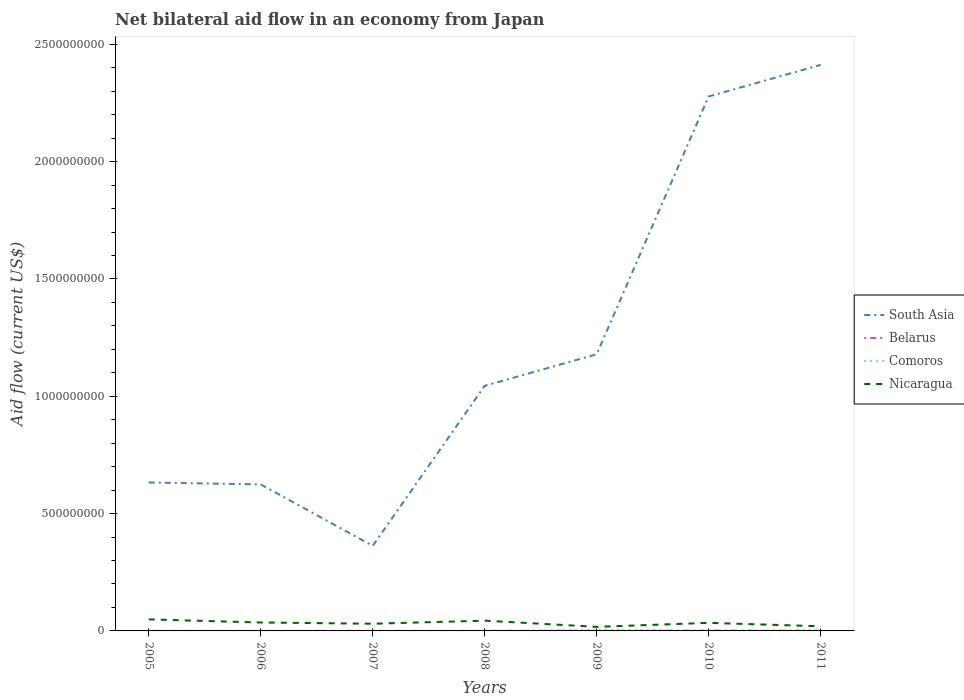How many different coloured lines are there?
Make the answer very short. 4. Does the line corresponding to South Asia intersect with the line corresponding to Belarus?
Your answer should be compact. No. Is the number of lines equal to the number of legend labels?
Keep it short and to the point. Yes. Across all years, what is the maximum net bilateral aid flow in Nicaragua?
Offer a terse response. 1.74e+07. In which year was the net bilateral aid flow in Comoros maximum?
Keep it short and to the point. 2007. What is the total net bilateral aid flow in South Asia in the graph?
Offer a terse response. -4.20e+08. What is the difference between the highest and the second highest net bilateral aid flow in Nicaragua?
Ensure brevity in your answer.  3.18e+07. Is the net bilateral aid flow in South Asia strictly greater than the net bilateral aid flow in Belarus over the years?
Ensure brevity in your answer.  No. How many lines are there?
Keep it short and to the point. 4. Does the graph contain any zero values?
Your answer should be compact. No. Does the graph contain grids?
Your answer should be very brief. No. Where does the legend appear in the graph?
Your answer should be compact. Center right. What is the title of the graph?
Your answer should be very brief. Net bilateral aid flow in an economy from Japan. What is the label or title of the X-axis?
Keep it short and to the point. Years. What is the Aid flow (current US$) in South Asia in 2005?
Make the answer very short. 6.33e+08. What is the Aid flow (current US$) in Nicaragua in 2005?
Offer a terse response. 4.92e+07. What is the Aid flow (current US$) of South Asia in 2006?
Provide a succinct answer. 6.24e+08. What is the Aid flow (current US$) in Belarus in 2006?
Ensure brevity in your answer.  1.60e+05. What is the Aid flow (current US$) of Nicaragua in 2006?
Offer a very short reply. 3.59e+07. What is the Aid flow (current US$) of South Asia in 2007?
Keep it short and to the point. 3.63e+08. What is the Aid flow (current US$) in Belarus in 2007?
Your answer should be very brief. 3.70e+05. What is the Aid flow (current US$) in Nicaragua in 2007?
Your answer should be very brief. 3.06e+07. What is the Aid flow (current US$) in South Asia in 2008?
Keep it short and to the point. 1.04e+09. What is the Aid flow (current US$) in Belarus in 2008?
Make the answer very short. 4.20e+05. What is the Aid flow (current US$) of Nicaragua in 2008?
Your response must be concise. 4.38e+07. What is the Aid flow (current US$) of South Asia in 2009?
Ensure brevity in your answer.  1.18e+09. What is the Aid flow (current US$) of Belarus in 2009?
Your answer should be compact. 5.70e+05. What is the Aid flow (current US$) in Comoros in 2009?
Offer a terse response. 5.30e+06. What is the Aid flow (current US$) of Nicaragua in 2009?
Offer a very short reply. 1.74e+07. What is the Aid flow (current US$) in South Asia in 2010?
Your answer should be very brief. 2.28e+09. What is the Aid flow (current US$) in Belarus in 2010?
Provide a succinct answer. 1.39e+06. What is the Aid flow (current US$) in Nicaragua in 2010?
Keep it short and to the point. 3.44e+07. What is the Aid flow (current US$) of South Asia in 2011?
Provide a succinct answer. 2.41e+09. What is the Aid flow (current US$) of Comoros in 2011?
Your response must be concise. 3.66e+06. What is the Aid flow (current US$) of Nicaragua in 2011?
Ensure brevity in your answer.  1.98e+07. Across all years, what is the maximum Aid flow (current US$) of South Asia?
Your response must be concise. 2.41e+09. Across all years, what is the maximum Aid flow (current US$) of Belarus?
Provide a succinct answer. 1.39e+06. Across all years, what is the maximum Aid flow (current US$) of Comoros?
Your response must be concise. 5.30e+06. Across all years, what is the maximum Aid flow (current US$) of Nicaragua?
Ensure brevity in your answer.  4.92e+07. Across all years, what is the minimum Aid flow (current US$) of South Asia?
Provide a short and direct response. 3.63e+08. Across all years, what is the minimum Aid flow (current US$) in Nicaragua?
Give a very brief answer. 1.74e+07. What is the total Aid flow (current US$) of South Asia in the graph?
Give a very brief answer. 8.53e+09. What is the total Aid flow (current US$) in Belarus in the graph?
Your response must be concise. 3.40e+06. What is the total Aid flow (current US$) in Comoros in the graph?
Your response must be concise. 9.79e+06. What is the total Aid flow (current US$) in Nicaragua in the graph?
Provide a succinct answer. 2.31e+08. What is the difference between the Aid flow (current US$) in South Asia in 2005 and that in 2006?
Keep it short and to the point. 8.14e+06. What is the difference between the Aid flow (current US$) in Comoros in 2005 and that in 2006?
Your response must be concise. -3.00e+04. What is the difference between the Aid flow (current US$) of Nicaragua in 2005 and that in 2006?
Provide a succinct answer. 1.33e+07. What is the difference between the Aid flow (current US$) in South Asia in 2005 and that in 2007?
Offer a terse response. 2.70e+08. What is the difference between the Aid flow (current US$) in Belarus in 2005 and that in 2007?
Your response must be concise. 4.00e+04. What is the difference between the Aid flow (current US$) of Comoros in 2005 and that in 2007?
Offer a terse response. 2.00e+04. What is the difference between the Aid flow (current US$) of Nicaragua in 2005 and that in 2007?
Your response must be concise. 1.86e+07. What is the difference between the Aid flow (current US$) of South Asia in 2005 and that in 2008?
Provide a short and direct response. -4.12e+08. What is the difference between the Aid flow (current US$) in Belarus in 2005 and that in 2008?
Provide a short and direct response. -10000. What is the difference between the Aid flow (current US$) in Nicaragua in 2005 and that in 2008?
Offer a terse response. 5.46e+06. What is the difference between the Aid flow (current US$) in South Asia in 2005 and that in 2009?
Your answer should be compact. -5.47e+08. What is the difference between the Aid flow (current US$) of Belarus in 2005 and that in 2009?
Offer a very short reply. -1.60e+05. What is the difference between the Aid flow (current US$) of Comoros in 2005 and that in 2009?
Keep it short and to the point. -5.27e+06. What is the difference between the Aid flow (current US$) in Nicaragua in 2005 and that in 2009?
Provide a succinct answer. 3.18e+07. What is the difference between the Aid flow (current US$) in South Asia in 2005 and that in 2010?
Offer a terse response. -1.65e+09. What is the difference between the Aid flow (current US$) of Belarus in 2005 and that in 2010?
Your response must be concise. -9.80e+05. What is the difference between the Aid flow (current US$) of Comoros in 2005 and that in 2010?
Make the answer very short. -6.70e+05. What is the difference between the Aid flow (current US$) of Nicaragua in 2005 and that in 2010?
Provide a short and direct response. 1.49e+07. What is the difference between the Aid flow (current US$) in South Asia in 2005 and that in 2011?
Give a very brief answer. -1.78e+09. What is the difference between the Aid flow (current US$) of Belarus in 2005 and that in 2011?
Offer a terse response. 3.30e+05. What is the difference between the Aid flow (current US$) in Comoros in 2005 and that in 2011?
Provide a short and direct response. -3.63e+06. What is the difference between the Aid flow (current US$) of Nicaragua in 2005 and that in 2011?
Offer a terse response. 2.94e+07. What is the difference between the Aid flow (current US$) in South Asia in 2006 and that in 2007?
Your response must be concise. 2.62e+08. What is the difference between the Aid flow (current US$) in Belarus in 2006 and that in 2007?
Offer a very short reply. -2.10e+05. What is the difference between the Aid flow (current US$) in Comoros in 2006 and that in 2007?
Your response must be concise. 5.00e+04. What is the difference between the Aid flow (current US$) in Nicaragua in 2006 and that in 2007?
Your response must be concise. 5.29e+06. What is the difference between the Aid flow (current US$) in South Asia in 2006 and that in 2008?
Offer a very short reply. -4.20e+08. What is the difference between the Aid flow (current US$) in Comoros in 2006 and that in 2008?
Your response must be concise. 3.00e+04. What is the difference between the Aid flow (current US$) of Nicaragua in 2006 and that in 2008?
Offer a terse response. -7.84e+06. What is the difference between the Aid flow (current US$) of South Asia in 2006 and that in 2009?
Offer a terse response. -5.55e+08. What is the difference between the Aid flow (current US$) in Belarus in 2006 and that in 2009?
Your answer should be very brief. -4.10e+05. What is the difference between the Aid flow (current US$) in Comoros in 2006 and that in 2009?
Offer a very short reply. -5.24e+06. What is the difference between the Aid flow (current US$) in Nicaragua in 2006 and that in 2009?
Your answer should be very brief. 1.85e+07. What is the difference between the Aid flow (current US$) of South Asia in 2006 and that in 2010?
Make the answer very short. -1.65e+09. What is the difference between the Aid flow (current US$) of Belarus in 2006 and that in 2010?
Your answer should be compact. -1.23e+06. What is the difference between the Aid flow (current US$) in Comoros in 2006 and that in 2010?
Your answer should be very brief. -6.40e+05. What is the difference between the Aid flow (current US$) of Nicaragua in 2006 and that in 2010?
Your answer should be very brief. 1.56e+06. What is the difference between the Aid flow (current US$) in South Asia in 2006 and that in 2011?
Offer a very short reply. -1.79e+09. What is the difference between the Aid flow (current US$) of Belarus in 2006 and that in 2011?
Give a very brief answer. 8.00e+04. What is the difference between the Aid flow (current US$) in Comoros in 2006 and that in 2011?
Provide a short and direct response. -3.60e+06. What is the difference between the Aid flow (current US$) in Nicaragua in 2006 and that in 2011?
Keep it short and to the point. 1.61e+07. What is the difference between the Aid flow (current US$) of South Asia in 2007 and that in 2008?
Keep it short and to the point. -6.82e+08. What is the difference between the Aid flow (current US$) in Belarus in 2007 and that in 2008?
Ensure brevity in your answer.  -5.00e+04. What is the difference between the Aid flow (current US$) of Nicaragua in 2007 and that in 2008?
Offer a terse response. -1.31e+07. What is the difference between the Aid flow (current US$) of South Asia in 2007 and that in 2009?
Give a very brief answer. -8.16e+08. What is the difference between the Aid flow (current US$) in Comoros in 2007 and that in 2009?
Keep it short and to the point. -5.29e+06. What is the difference between the Aid flow (current US$) of Nicaragua in 2007 and that in 2009?
Your answer should be compact. 1.32e+07. What is the difference between the Aid flow (current US$) in South Asia in 2007 and that in 2010?
Offer a very short reply. -1.92e+09. What is the difference between the Aid flow (current US$) in Belarus in 2007 and that in 2010?
Your answer should be very brief. -1.02e+06. What is the difference between the Aid flow (current US$) in Comoros in 2007 and that in 2010?
Your response must be concise. -6.90e+05. What is the difference between the Aid flow (current US$) of Nicaragua in 2007 and that in 2010?
Your answer should be very brief. -3.73e+06. What is the difference between the Aid flow (current US$) of South Asia in 2007 and that in 2011?
Provide a short and direct response. -2.05e+09. What is the difference between the Aid flow (current US$) in Comoros in 2007 and that in 2011?
Your answer should be compact. -3.65e+06. What is the difference between the Aid flow (current US$) of Nicaragua in 2007 and that in 2011?
Provide a short and direct response. 1.08e+07. What is the difference between the Aid flow (current US$) in South Asia in 2008 and that in 2009?
Keep it short and to the point. -1.35e+08. What is the difference between the Aid flow (current US$) of Belarus in 2008 and that in 2009?
Your answer should be very brief. -1.50e+05. What is the difference between the Aid flow (current US$) in Comoros in 2008 and that in 2009?
Provide a short and direct response. -5.27e+06. What is the difference between the Aid flow (current US$) in Nicaragua in 2008 and that in 2009?
Offer a very short reply. 2.64e+07. What is the difference between the Aid flow (current US$) of South Asia in 2008 and that in 2010?
Offer a very short reply. -1.23e+09. What is the difference between the Aid flow (current US$) in Belarus in 2008 and that in 2010?
Offer a very short reply. -9.70e+05. What is the difference between the Aid flow (current US$) in Comoros in 2008 and that in 2010?
Provide a short and direct response. -6.70e+05. What is the difference between the Aid flow (current US$) of Nicaragua in 2008 and that in 2010?
Provide a succinct answer. 9.40e+06. What is the difference between the Aid flow (current US$) in South Asia in 2008 and that in 2011?
Provide a succinct answer. -1.37e+09. What is the difference between the Aid flow (current US$) in Comoros in 2008 and that in 2011?
Provide a succinct answer. -3.63e+06. What is the difference between the Aid flow (current US$) in Nicaragua in 2008 and that in 2011?
Provide a succinct answer. 2.40e+07. What is the difference between the Aid flow (current US$) in South Asia in 2009 and that in 2010?
Ensure brevity in your answer.  -1.10e+09. What is the difference between the Aid flow (current US$) of Belarus in 2009 and that in 2010?
Offer a very short reply. -8.20e+05. What is the difference between the Aid flow (current US$) of Comoros in 2009 and that in 2010?
Your answer should be very brief. 4.60e+06. What is the difference between the Aid flow (current US$) of Nicaragua in 2009 and that in 2010?
Your answer should be compact. -1.70e+07. What is the difference between the Aid flow (current US$) of South Asia in 2009 and that in 2011?
Provide a short and direct response. -1.23e+09. What is the difference between the Aid flow (current US$) in Belarus in 2009 and that in 2011?
Make the answer very short. 4.90e+05. What is the difference between the Aid flow (current US$) of Comoros in 2009 and that in 2011?
Offer a very short reply. 1.64e+06. What is the difference between the Aid flow (current US$) of Nicaragua in 2009 and that in 2011?
Your answer should be compact. -2.41e+06. What is the difference between the Aid flow (current US$) of South Asia in 2010 and that in 2011?
Make the answer very short. -1.35e+08. What is the difference between the Aid flow (current US$) of Belarus in 2010 and that in 2011?
Provide a succinct answer. 1.31e+06. What is the difference between the Aid flow (current US$) in Comoros in 2010 and that in 2011?
Keep it short and to the point. -2.96e+06. What is the difference between the Aid flow (current US$) in Nicaragua in 2010 and that in 2011?
Keep it short and to the point. 1.46e+07. What is the difference between the Aid flow (current US$) of South Asia in 2005 and the Aid flow (current US$) of Belarus in 2006?
Provide a short and direct response. 6.32e+08. What is the difference between the Aid flow (current US$) of South Asia in 2005 and the Aid flow (current US$) of Comoros in 2006?
Your answer should be compact. 6.33e+08. What is the difference between the Aid flow (current US$) in South Asia in 2005 and the Aid flow (current US$) in Nicaragua in 2006?
Your response must be concise. 5.97e+08. What is the difference between the Aid flow (current US$) in Belarus in 2005 and the Aid flow (current US$) in Comoros in 2006?
Make the answer very short. 3.50e+05. What is the difference between the Aid flow (current US$) in Belarus in 2005 and the Aid flow (current US$) in Nicaragua in 2006?
Your answer should be very brief. -3.55e+07. What is the difference between the Aid flow (current US$) of Comoros in 2005 and the Aid flow (current US$) of Nicaragua in 2006?
Offer a very short reply. -3.59e+07. What is the difference between the Aid flow (current US$) in South Asia in 2005 and the Aid flow (current US$) in Belarus in 2007?
Offer a very short reply. 6.32e+08. What is the difference between the Aid flow (current US$) in South Asia in 2005 and the Aid flow (current US$) in Comoros in 2007?
Ensure brevity in your answer.  6.33e+08. What is the difference between the Aid flow (current US$) in South Asia in 2005 and the Aid flow (current US$) in Nicaragua in 2007?
Offer a very short reply. 6.02e+08. What is the difference between the Aid flow (current US$) in Belarus in 2005 and the Aid flow (current US$) in Nicaragua in 2007?
Ensure brevity in your answer.  -3.02e+07. What is the difference between the Aid flow (current US$) in Comoros in 2005 and the Aid flow (current US$) in Nicaragua in 2007?
Your response must be concise. -3.06e+07. What is the difference between the Aid flow (current US$) in South Asia in 2005 and the Aid flow (current US$) in Belarus in 2008?
Your answer should be compact. 6.32e+08. What is the difference between the Aid flow (current US$) in South Asia in 2005 and the Aid flow (current US$) in Comoros in 2008?
Give a very brief answer. 6.33e+08. What is the difference between the Aid flow (current US$) of South Asia in 2005 and the Aid flow (current US$) of Nicaragua in 2008?
Your answer should be compact. 5.89e+08. What is the difference between the Aid flow (current US$) of Belarus in 2005 and the Aid flow (current US$) of Comoros in 2008?
Keep it short and to the point. 3.80e+05. What is the difference between the Aid flow (current US$) in Belarus in 2005 and the Aid flow (current US$) in Nicaragua in 2008?
Offer a terse response. -4.34e+07. What is the difference between the Aid flow (current US$) of Comoros in 2005 and the Aid flow (current US$) of Nicaragua in 2008?
Offer a very short reply. -4.37e+07. What is the difference between the Aid flow (current US$) in South Asia in 2005 and the Aid flow (current US$) in Belarus in 2009?
Your answer should be compact. 6.32e+08. What is the difference between the Aid flow (current US$) in South Asia in 2005 and the Aid flow (current US$) in Comoros in 2009?
Keep it short and to the point. 6.27e+08. What is the difference between the Aid flow (current US$) in South Asia in 2005 and the Aid flow (current US$) in Nicaragua in 2009?
Keep it short and to the point. 6.15e+08. What is the difference between the Aid flow (current US$) of Belarus in 2005 and the Aid flow (current US$) of Comoros in 2009?
Your answer should be compact. -4.89e+06. What is the difference between the Aid flow (current US$) in Belarus in 2005 and the Aid flow (current US$) in Nicaragua in 2009?
Your response must be concise. -1.70e+07. What is the difference between the Aid flow (current US$) of Comoros in 2005 and the Aid flow (current US$) of Nicaragua in 2009?
Give a very brief answer. -1.74e+07. What is the difference between the Aid flow (current US$) of South Asia in 2005 and the Aid flow (current US$) of Belarus in 2010?
Your response must be concise. 6.31e+08. What is the difference between the Aid flow (current US$) in South Asia in 2005 and the Aid flow (current US$) in Comoros in 2010?
Keep it short and to the point. 6.32e+08. What is the difference between the Aid flow (current US$) of South Asia in 2005 and the Aid flow (current US$) of Nicaragua in 2010?
Provide a short and direct response. 5.98e+08. What is the difference between the Aid flow (current US$) in Belarus in 2005 and the Aid flow (current US$) in Comoros in 2010?
Give a very brief answer. -2.90e+05. What is the difference between the Aid flow (current US$) of Belarus in 2005 and the Aid flow (current US$) of Nicaragua in 2010?
Keep it short and to the point. -3.40e+07. What is the difference between the Aid flow (current US$) of Comoros in 2005 and the Aid flow (current US$) of Nicaragua in 2010?
Provide a succinct answer. -3.43e+07. What is the difference between the Aid flow (current US$) in South Asia in 2005 and the Aid flow (current US$) in Belarus in 2011?
Make the answer very short. 6.33e+08. What is the difference between the Aid flow (current US$) of South Asia in 2005 and the Aid flow (current US$) of Comoros in 2011?
Provide a succinct answer. 6.29e+08. What is the difference between the Aid flow (current US$) of South Asia in 2005 and the Aid flow (current US$) of Nicaragua in 2011?
Your response must be concise. 6.13e+08. What is the difference between the Aid flow (current US$) of Belarus in 2005 and the Aid flow (current US$) of Comoros in 2011?
Your answer should be very brief. -3.25e+06. What is the difference between the Aid flow (current US$) of Belarus in 2005 and the Aid flow (current US$) of Nicaragua in 2011?
Offer a very short reply. -1.94e+07. What is the difference between the Aid flow (current US$) in Comoros in 2005 and the Aid flow (current US$) in Nicaragua in 2011?
Offer a terse response. -1.98e+07. What is the difference between the Aid flow (current US$) of South Asia in 2006 and the Aid flow (current US$) of Belarus in 2007?
Ensure brevity in your answer.  6.24e+08. What is the difference between the Aid flow (current US$) of South Asia in 2006 and the Aid flow (current US$) of Comoros in 2007?
Ensure brevity in your answer.  6.24e+08. What is the difference between the Aid flow (current US$) of South Asia in 2006 and the Aid flow (current US$) of Nicaragua in 2007?
Ensure brevity in your answer.  5.94e+08. What is the difference between the Aid flow (current US$) of Belarus in 2006 and the Aid flow (current US$) of Nicaragua in 2007?
Your response must be concise. -3.05e+07. What is the difference between the Aid flow (current US$) of Comoros in 2006 and the Aid flow (current US$) of Nicaragua in 2007?
Keep it short and to the point. -3.06e+07. What is the difference between the Aid flow (current US$) of South Asia in 2006 and the Aid flow (current US$) of Belarus in 2008?
Make the answer very short. 6.24e+08. What is the difference between the Aid flow (current US$) of South Asia in 2006 and the Aid flow (current US$) of Comoros in 2008?
Make the answer very short. 6.24e+08. What is the difference between the Aid flow (current US$) in South Asia in 2006 and the Aid flow (current US$) in Nicaragua in 2008?
Offer a very short reply. 5.81e+08. What is the difference between the Aid flow (current US$) in Belarus in 2006 and the Aid flow (current US$) in Comoros in 2008?
Your answer should be very brief. 1.30e+05. What is the difference between the Aid flow (current US$) in Belarus in 2006 and the Aid flow (current US$) in Nicaragua in 2008?
Provide a succinct answer. -4.36e+07. What is the difference between the Aid flow (current US$) of Comoros in 2006 and the Aid flow (current US$) of Nicaragua in 2008?
Keep it short and to the point. -4.37e+07. What is the difference between the Aid flow (current US$) in South Asia in 2006 and the Aid flow (current US$) in Belarus in 2009?
Provide a succinct answer. 6.24e+08. What is the difference between the Aid flow (current US$) of South Asia in 2006 and the Aid flow (current US$) of Comoros in 2009?
Offer a very short reply. 6.19e+08. What is the difference between the Aid flow (current US$) of South Asia in 2006 and the Aid flow (current US$) of Nicaragua in 2009?
Ensure brevity in your answer.  6.07e+08. What is the difference between the Aid flow (current US$) in Belarus in 2006 and the Aid flow (current US$) in Comoros in 2009?
Your answer should be compact. -5.14e+06. What is the difference between the Aid flow (current US$) of Belarus in 2006 and the Aid flow (current US$) of Nicaragua in 2009?
Your answer should be very brief. -1.72e+07. What is the difference between the Aid flow (current US$) in Comoros in 2006 and the Aid flow (current US$) in Nicaragua in 2009?
Your response must be concise. -1.73e+07. What is the difference between the Aid flow (current US$) in South Asia in 2006 and the Aid flow (current US$) in Belarus in 2010?
Your answer should be compact. 6.23e+08. What is the difference between the Aid flow (current US$) of South Asia in 2006 and the Aid flow (current US$) of Comoros in 2010?
Your answer should be very brief. 6.24e+08. What is the difference between the Aid flow (current US$) in South Asia in 2006 and the Aid flow (current US$) in Nicaragua in 2010?
Offer a terse response. 5.90e+08. What is the difference between the Aid flow (current US$) in Belarus in 2006 and the Aid flow (current US$) in Comoros in 2010?
Make the answer very short. -5.40e+05. What is the difference between the Aid flow (current US$) in Belarus in 2006 and the Aid flow (current US$) in Nicaragua in 2010?
Keep it short and to the point. -3.42e+07. What is the difference between the Aid flow (current US$) in Comoros in 2006 and the Aid flow (current US$) in Nicaragua in 2010?
Ensure brevity in your answer.  -3.43e+07. What is the difference between the Aid flow (current US$) in South Asia in 2006 and the Aid flow (current US$) in Belarus in 2011?
Your answer should be compact. 6.24e+08. What is the difference between the Aid flow (current US$) of South Asia in 2006 and the Aid flow (current US$) of Comoros in 2011?
Give a very brief answer. 6.21e+08. What is the difference between the Aid flow (current US$) of South Asia in 2006 and the Aid flow (current US$) of Nicaragua in 2011?
Your answer should be compact. 6.05e+08. What is the difference between the Aid flow (current US$) of Belarus in 2006 and the Aid flow (current US$) of Comoros in 2011?
Provide a succinct answer. -3.50e+06. What is the difference between the Aid flow (current US$) of Belarus in 2006 and the Aid flow (current US$) of Nicaragua in 2011?
Offer a very short reply. -1.96e+07. What is the difference between the Aid flow (current US$) in Comoros in 2006 and the Aid flow (current US$) in Nicaragua in 2011?
Provide a short and direct response. -1.97e+07. What is the difference between the Aid flow (current US$) in South Asia in 2007 and the Aid flow (current US$) in Belarus in 2008?
Keep it short and to the point. 3.62e+08. What is the difference between the Aid flow (current US$) in South Asia in 2007 and the Aid flow (current US$) in Comoros in 2008?
Your answer should be very brief. 3.63e+08. What is the difference between the Aid flow (current US$) of South Asia in 2007 and the Aid flow (current US$) of Nicaragua in 2008?
Make the answer very short. 3.19e+08. What is the difference between the Aid flow (current US$) in Belarus in 2007 and the Aid flow (current US$) in Comoros in 2008?
Provide a short and direct response. 3.40e+05. What is the difference between the Aid flow (current US$) of Belarus in 2007 and the Aid flow (current US$) of Nicaragua in 2008?
Provide a succinct answer. -4.34e+07. What is the difference between the Aid flow (current US$) in Comoros in 2007 and the Aid flow (current US$) in Nicaragua in 2008?
Keep it short and to the point. -4.38e+07. What is the difference between the Aid flow (current US$) in South Asia in 2007 and the Aid flow (current US$) in Belarus in 2009?
Provide a short and direct response. 3.62e+08. What is the difference between the Aid flow (current US$) in South Asia in 2007 and the Aid flow (current US$) in Comoros in 2009?
Provide a succinct answer. 3.57e+08. What is the difference between the Aid flow (current US$) of South Asia in 2007 and the Aid flow (current US$) of Nicaragua in 2009?
Make the answer very short. 3.45e+08. What is the difference between the Aid flow (current US$) of Belarus in 2007 and the Aid flow (current US$) of Comoros in 2009?
Offer a terse response. -4.93e+06. What is the difference between the Aid flow (current US$) in Belarus in 2007 and the Aid flow (current US$) in Nicaragua in 2009?
Offer a very short reply. -1.70e+07. What is the difference between the Aid flow (current US$) of Comoros in 2007 and the Aid flow (current US$) of Nicaragua in 2009?
Make the answer very short. -1.74e+07. What is the difference between the Aid flow (current US$) of South Asia in 2007 and the Aid flow (current US$) of Belarus in 2010?
Your response must be concise. 3.61e+08. What is the difference between the Aid flow (current US$) in South Asia in 2007 and the Aid flow (current US$) in Comoros in 2010?
Make the answer very short. 3.62e+08. What is the difference between the Aid flow (current US$) in South Asia in 2007 and the Aid flow (current US$) in Nicaragua in 2010?
Give a very brief answer. 3.28e+08. What is the difference between the Aid flow (current US$) of Belarus in 2007 and the Aid flow (current US$) of Comoros in 2010?
Your answer should be very brief. -3.30e+05. What is the difference between the Aid flow (current US$) in Belarus in 2007 and the Aid flow (current US$) in Nicaragua in 2010?
Your response must be concise. -3.40e+07. What is the difference between the Aid flow (current US$) of Comoros in 2007 and the Aid flow (current US$) of Nicaragua in 2010?
Your response must be concise. -3.44e+07. What is the difference between the Aid flow (current US$) in South Asia in 2007 and the Aid flow (current US$) in Belarus in 2011?
Your answer should be very brief. 3.63e+08. What is the difference between the Aid flow (current US$) of South Asia in 2007 and the Aid flow (current US$) of Comoros in 2011?
Provide a short and direct response. 3.59e+08. What is the difference between the Aid flow (current US$) of South Asia in 2007 and the Aid flow (current US$) of Nicaragua in 2011?
Your answer should be very brief. 3.43e+08. What is the difference between the Aid flow (current US$) in Belarus in 2007 and the Aid flow (current US$) in Comoros in 2011?
Offer a terse response. -3.29e+06. What is the difference between the Aid flow (current US$) of Belarus in 2007 and the Aid flow (current US$) of Nicaragua in 2011?
Keep it short and to the point. -1.94e+07. What is the difference between the Aid flow (current US$) of Comoros in 2007 and the Aid flow (current US$) of Nicaragua in 2011?
Provide a succinct answer. -1.98e+07. What is the difference between the Aid flow (current US$) in South Asia in 2008 and the Aid flow (current US$) in Belarus in 2009?
Ensure brevity in your answer.  1.04e+09. What is the difference between the Aid flow (current US$) of South Asia in 2008 and the Aid flow (current US$) of Comoros in 2009?
Ensure brevity in your answer.  1.04e+09. What is the difference between the Aid flow (current US$) in South Asia in 2008 and the Aid flow (current US$) in Nicaragua in 2009?
Your answer should be compact. 1.03e+09. What is the difference between the Aid flow (current US$) of Belarus in 2008 and the Aid flow (current US$) of Comoros in 2009?
Provide a short and direct response. -4.88e+06. What is the difference between the Aid flow (current US$) in Belarus in 2008 and the Aid flow (current US$) in Nicaragua in 2009?
Give a very brief answer. -1.70e+07. What is the difference between the Aid flow (current US$) of Comoros in 2008 and the Aid flow (current US$) of Nicaragua in 2009?
Ensure brevity in your answer.  -1.74e+07. What is the difference between the Aid flow (current US$) of South Asia in 2008 and the Aid flow (current US$) of Belarus in 2010?
Make the answer very short. 1.04e+09. What is the difference between the Aid flow (current US$) in South Asia in 2008 and the Aid flow (current US$) in Comoros in 2010?
Provide a succinct answer. 1.04e+09. What is the difference between the Aid flow (current US$) of South Asia in 2008 and the Aid flow (current US$) of Nicaragua in 2010?
Provide a short and direct response. 1.01e+09. What is the difference between the Aid flow (current US$) in Belarus in 2008 and the Aid flow (current US$) in Comoros in 2010?
Ensure brevity in your answer.  -2.80e+05. What is the difference between the Aid flow (current US$) in Belarus in 2008 and the Aid flow (current US$) in Nicaragua in 2010?
Provide a succinct answer. -3.40e+07. What is the difference between the Aid flow (current US$) in Comoros in 2008 and the Aid flow (current US$) in Nicaragua in 2010?
Keep it short and to the point. -3.43e+07. What is the difference between the Aid flow (current US$) of South Asia in 2008 and the Aid flow (current US$) of Belarus in 2011?
Keep it short and to the point. 1.04e+09. What is the difference between the Aid flow (current US$) in South Asia in 2008 and the Aid flow (current US$) in Comoros in 2011?
Give a very brief answer. 1.04e+09. What is the difference between the Aid flow (current US$) of South Asia in 2008 and the Aid flow (current US$) of Nicaragua in 2011?
Your response must be concise. 1.02e+09. What is the difference between the Aid flow (current US$) of Belarus in 2008 and the Aid flow (current US$) of Comoros in 2011?
Provide a short and direct response. -3.24e+06. What is the difference between the Aid flow (current US$) of Belarus in 2008 and the Aid flow (current US$) of Nicaragua in 2011?
Make the answer very short. -1.94e+07. What is the difference between the Aid flow (current US$) in Comoros in 2008 and the Aid flow (current US$) in Nicaragua in 2011?
Give a very brief answer. -1.98e+07. What is the difference between the Aid flow (current US$) of South Asia in 2009 and the Aid flow (current US$) of Belarus in 2010?
Ensure brevity in your answer.  1.18e+09. What is the difference between the Aid flow (current US$) in South Asia in 2009 and the Aid flow (current US$) in Comoros in 2010?
Give a very brief answer. 1.18e+09. What is the difference between the Aid flow (current US$) in South Asia in 2009 and the Aid flow (current US$) in Nicaragua in 2010?
Your answer should be very brief. 1.14e+09. What is the difference between the Aid flow (current US$) of Belarus in 2009 and the Aid flow (current US$) of Nicaragua in 2010?
Keep it short and to the point. -3.38e+07. What is the difference between the Aid flow (current US$) of Comoros in 2009 and the Aid flow (current US$) of Nicaragua in 2010?
Your answer should be compact. -2.91e+07. What is the difference between the Aid flow (current US$) in South Asia in 2009 and the Aid flow (current US$) in Belarus in 2011?
Give a very brief answer. 1.18e+09. What is the difference between the Aid flow (current US$) in South Asia in 2009 and the Aid flow (current US$) in Comoros in 2011?
Your response must be concise. 1.18e+09. What is the difference between the Aid flow (current US$) in South Asia in 2009 and the Aid flow (current US$) in Nicaragua in 2011?
Your answer should be compact. 1.16e+09. What is the difference between the Aid flow (current US$) in Belarus in 2009 and the Aid flow (current US$) in Comoros in 2011?
Ensure brevity in your answer.  -3.09e+06. What is the difference between the Aid flow (current US$) of Belarus in 2009 and the Aid flow (current US$) of Nicaragua in 2011?
Your response must be concise. -1.92e+07. What is the difference between the Aid flow (current US$) in Comoros in 2009 and the Aid flow (current US$) in Nicaragua in 2011?
Your answer should be compact. -1.45e+07. What is the difference between the Aid flow (current US$) of South Asia in 2010 and the Aid flow (current US$) of Belarus in 2011?
Your answer should be compact. 2.28e+09. What is the difference between the Aid flow (current US$) of South Asia in 2010 and the Aid flow (current US$) of Comoros in 2011?
Provide a short and direct response. 2.27e+09. What is the difference between the Aid flow (current US$) of South Asia in 2010 and the Aid flow (current US$) of Nicaragua in 2011?
Make the answer very short. 2.26e+09. What is the difference between the Aid flow (current US$) of Belarus in 2010 and the Aid flow (current US$) of Comoros in 2011?
Provide a succinct answer. -2.27e+06. What is the difference between the Aid flow (current US$) of Belarus in 2010 and the Aid flow (current US$) of Nicaragua in 2011?
Your answer should be very brief. -1.84e+07. What is the difference between the Aid flow (current US$) of Comoros in 2010 and the Aid flow (current US$) of Nicaragua in 2011?
Your answer should be compact. -1.91e+07. What is the average Aid flow (current US$) in South Asia per year?
Make the answer very short. 1.22e+09. What is the average Aid flow (current US$) of Belarus per year?
Make the answer very short. 4.86e+05. What is the average Aid flow (current US$) of Comoros per year?
Ensure brevity in your answer.  1.40e+06. What is the average Aid flow (current US$) of Nicaragua per year?
Provide a short and direct response. 3.30e+07. In the year 2005, what is the difference between the Aid flow (current US$) in South Asia and Aid flow (current US$) in Belarus?
Your answer should be very brief. 6.32e+08. In the year 2005, what is the difference between the Aid flow (current US$) in South Asia and Aid flow (current US$) in Comoros?
Give a very brief answer. 6.33e+08. In the year 2005, what is the difference between the Aid flow (current US$) of South Asia and Aid flow (current US$) of Nicaragua?
Keep it short and to the point. 5.83e+08. In the year 2005, what is the difference between the Aid flow (current US$) of Belarus and Aid flow (current US$) of Comoros?
Your response must be concise. 3.80e+05. In the year 2005, what is the difference between the Aid flow (current US$) of Belarus and Aid flow (current US$) of Nicaragua?
Your answer should be very brief. -4.88e+07. In the year 2005, what is the difference between the Aid flow (current US$) in Comoros and Aid flow (current US$) in Nicaragua?
Provide a short and direct response. -4.92e+07. In the year 2006, what is the difference between the Aid flow (current US$) of South Asia and Aid flow (current US$) of Belarus?
Your answer should be very brief. 6.24e+08. In the year 2006, what is the difference between the Aid flow (current US$) in South Asia and Aid flow (current US$) in Comoros?
Provide a short and direct response. 6.24e+08. In the year 2006, what is the difference between the Aid flow (current US$) of South Asia and Aid flow (current US$) of Nicaragua?
Keep it short and to the point. 5.89e+08. In the year 2006, what is the difference between the Aid flow (current US$) in Belarus and Aid flow (current US$) in Comoros?
Ensure brevity in your answer.  1.00e+05. In the year 2006, what is the difference between the Aid flow (current US$) in Belarus and Aid flow (current US$) in Nicaragua?
Your response must be concise. -3.58e+07. In the year 2006, what is the difference between the Aid flow (current US$) in Comoros and Aid flow (current US$) in Nicaragua?
Provide a succinct answer. -3.59e+07. In the year 2007, what is the difference between the Aid flow (current US$) of South Asia and Aid flow (current US$) of Belarus?
Keep it short and to the point. 3.62e+08. In the year 2007, what is the difference between the Aid flow (current US$) in South Asia and Aid flow (current US$) in Comoros?
Your response must be concise. 3.63e+08. In the year 2007, what is the difference between the Aid flow (current US$) of South Asia and Aid flow (current US$) of Nicaragua?
Keep it short and to the point. 3.32e+08. In the year 2007, what is the difference between the Aid flow (current US$) in Belarus and Aid flow (current US$) in Nicaragua?
Your answer should be compact. -3.03e+07. In the year 2007, what is the difference between the Aid flow (current US$) in Comoros and Aid flow (current US$) in Nicaragua?
Your response must be concise. -3.06e+07. In the year 2008, what is the difference between the Aid flow (current US$) in South Asia and Aid flow (current US$) in Belarus?
Provide a short and direct response. 1.04e+09. In the year 2008, what is the difference between the Aid flow (current US$) of South Asia and Aid flow (current US$) of Comoros?
Provide a short and direct response. 1.04e+09. In the year 2008, what is the difference between the Aid flow (current US$) in South Asia and Aid flow (current US$) in Nicaragua?
Provide a succinct answer. 1.00e+09. In the year 2008, what is the difference between the Aid flow (current US$) of Belarus and Aid flow (current US$) of Comoros?
Offer a terse response. 3.90e+05. In the year 2008, what is the difference between the Aid flow (current US$) in Belarus and Aid flow (current US$) in Nicaragua?
Ensure brevity in your answer.  -4.34e+07. In the year 2008, what is the difference between the Aid flow (current US$) in Comoros and Aid flow (current US$) in Nicaragua?
Provide a succinct answer. -4.37e+07. In the year 2009, what is the difference between the Aid flow (current US$) of South Asia and Aid flow (current US$) of Belarus?
Provide a succinct answer. 1.18e+09. In the year 2009, what is the difference between the Aid flow (current US$) of South Asia and Aid flow (current US$) of Comoros?
Your answer should be very brief. 1.17e+09. In the year 2009, what is the difference between the Aid flow (current US$) of South Asia and Aid flow (current US$) of Nicaragua?
Offer a very short reply. 1.16e+09. In the year 2009, what is the difference between the Aid flow (current US$) of Belarus and Aid flow (current US$) of Comoros?
Provide a succinct answer. -4.73e+06. In the year 2009, what is the difference between the Aid flow (current US$) in Belarus and Aid flow (current US$) in Nicaragua?
Offer a very short reply. -1.68e+07. In the year 2009, what is the difference between the Aid flow (current US$) of Comoros and Aid flow (current US$) of Nicaragua?
Offer a terse response. -1.21e+07. In the year 2010, what is the difference between the Aid flow (current US$) of South Asia and Aid flow (current US$) of Belarus?
Provide a short and direct response. 2.28e+09. In the year 2010, what is the difference between the Aid flow (current US$) in South Asia and Aid flow (current US$) in Comoros?
Offer a very short reply. 2.28e+09. In the year 2010, what is the difference between the Aid flow (current US$) in South Asia and Aid flow (current US$) in Nicaragua?
Provide a short and direct response. 2.24e+09. In the year 2010, what is the difference between the Aid flow (current US$) in Belarus and Aid flow (current US$) in Comoros?
Provide a succinct answer. 6.90e+05. In the year 2010, what is the difference between the Aid flow (current US$) of Belarus and Aid flow (current US$) of Nicaragua?
Your answer should be compact. -3.30e+07. In the year 2010, what is the difference between the Aid flow (current US$) in Comoros and Aid flow (current US$) in Nicaragua?
Your response must be concise. -3.37e+07. In the year 2011, what is the difference between the Aid flow (current US$) of South Asia and Aid flow (current US$) of Belarus?
Offer a very short reply. 2.41e+09. In the year 2011, what is the difference between the Aid flow (current US$) in South Asia and Aid flow (current US$) in Comoros?
Keep it short and to the point. 2.41e+09. In the year 2011, what is the difference between the Aid flow (current US$) in South Asia and Aid flow (current US$) in Nicaragua?
Your answer should be compact. 2.39e+09. In the year 2011, what is the difference between the Aid flow (current US$) of Belarus and Aid flow (current US$) of Comoros?
Provide a short and direct response. -3.58e+06. In the year 2011, what is the difference between the Aid flow (current US$) in Belarus and Aid flow (current US$) in Nicaragua?
Offer a very short reply. -1.97e+07. In the year 2011, what is the difference between the Aid flow (current US$) in Comoros and Aid flow (current US$) in Nicaragua?
Provide a short and direct response. -1.61e+07. What is the ratio of the Aid flow (current US$) in South Asia in 2005 to that in 2006?
Offer a very short reply. 1.01. What is the ratio of the Aid flow (current US$) in Belarus in 2005 to that in 2006?
Provide a succinct answer. 2.56. What is the ratio of the Aid flow (current US$) of Comoros in 2005 to that in 2006?
Offer a very short reply. 0.5. What is the ratio of the Aid flow (current US$) of Nicaragua in 2005 to that in 2006?
Ensure brevity in your answer.  1.37. What is the ratio of the Aid flow (current US$) of South Asia in 2005 to that in 2007?
Your response must be concise. 1.74. What is the ratio of the Aid flow (current US$) of Belarus in 2005 to that in 2007?
Your answer should be very brief. 1.11. What is the ratio of the Aid flow (current US$) in Comoros in 2005 to that in 2007?
Your answer should be very brief. 3. What is the ratio of the Aid flow (current US$) of Nicaragua in 2005 to that in 2007?
Keep it short and to the point. 1.61. What is the ratio of the Aid flow (current US$) of South Asia in 2005 to that in 2008?
Provide a succinct answer. 0.61. What is the ratio of the Aid flow (current US$) in Belarus in 2005 to that in 2008?
Keep it short and to the point. 0.98. What is the ratio of the Aid flow (current US$) in Comoros in 2005 to that in 2008?
Offer a terse response. 1. What is the ratio of the Aid flow (current US$) of Nicaragua in 2005 to that in 2008?
Offer a terse response. 1.12. What is the ratio of the Aid flow (current US$) of South Asia in 2005 to that in 2009?
Keep it short and to the point. 0.54. What is the ratio of the Aid flow (current US$) of Belarus in 2005 to that in 2009?
Give a very brief answer. 0.72. What is the ratio of the Aid flow (current US$) in Comoros in 2005 to that in 2009?
Your response must be concise. 0.01. What is the ratio of the Aid flow (current US$) in Nicaragua in 2005 to that in 2009?
Provide a succinct answer. 2.83. What is the ratio of the Aid flow (current US$) in South Asia in 2005 to that in 2010?
Ensure brevity in your answer.  0.28. What is the ratio of the Aid flow (current US$) of Belarus in 2005 to that in 2010?
Your answer should be very brief. 0.29. What is the ratio of the Aid flow (current US$) in Comoros in 2005 to that in 2010?
Your response must be concise. 0.04. What is the ratio of the Aid flow (current US$) in Nicaragua in 2005 to that in 2010?
Give a very brief answer. 1.43. What is the ratio of the Aid flow (current US$) of South Asia in 2005 to that in 2011?
Your answer should be compact. 0.26. What is the ratio of the Aid flow (current US$) in Belarus in 2005 to that in 2011?
Offer a very short reply. 5.12. What is the ratio of the Aid flow (current US$) of Comoros in 2005 to that in 2011?
Your answer should be very brief. 0.01. What is the ratio of the Aid flow (current US$) in Nicaragua in 2005 to that in 2011?
Your response must be concise. 2.49. What is the ratio of the Aid flow (current US$) in South Asia in 2006 to that in 2007?
Your answer should be very brief. 1.72. What is the ratio of the Aid flow (current US$) of Belarus in 2006 to that in 2007?
Offer a terse response. 0.43. What is the ratio of the Aid flow (current US$) in Comoros in 2006 to that in 2007?
Provide a short and direct response. 6. What is the ratio of the Aid flow (current US$) in Nicaragua in 2006 to that in 2007?
Ensure brevity in your answer.  1.17. What is the ratio of the Aid flow (current US$) in South Asia in 2006 to that in 2008?
Your answer should be very brief. 0.6. What is the ratio of the Aid flow (current US$) of Belarus in 2006 to that in 2008?
Your answer should be very brief. 0.38. What is the ratio of the Aid flow (current US$) of Comoros in 2006 to that in 2008?
Ensure brevity in your answer.  2. What is the ratio of the Aid flow (current US$) of Nicaragua in 2006 to that in 2008?
Offer a terse response. 0.82. What is the ratio of the Aid flow (current US$) in South Asia in 2006 to that in 2009?
Keep it short and to the point. 0.53. What is the ratio of the Aid flow (current US$) of Belarus in 2006 to that in 2009?
Your answer should be compact. 0.28. What is the ratio of the Aid flow (current US$) of Comoros in 2006 to that in 2009?
Provide a short and direct response. 0.01. What is the ratio of the Aid flow (current US$) of Nicaragua in 2006 to that in 2009?
Your answer should be compact. 2.07. What is the ratio of the Aid flow (current US$) in South Asia in 2006 to that in 2010?
Your response must be concise. 0.27. What is the ratio of the Aid flow (current US$) in Belarus in 2006 to that in 2010?
Offer a very short reply. 0.12. What is the ratio of the Aid flow (current US$) of Comoros in 2006 to that in 2010?
Give a very brief answer. 0.09. What is the ratio of the Aid flow (current US$) of Nicaragua in 2006 to that in 2010?
Your response must be concise. 1.05. What is the ratio of the Aid flow (current US$) in South Asia in 2006 to that in 2011?
Ensure brevity in your answer.  0.26. What is the ratio of the Aid flow (current US$) of Belarus in 2006 to that in 2011?
Your answer should be compact. 2. What is the ratio of the Aid flow (current US$) in Comoros in 2006 to that in 2011?
Your response must be concise. 0.02. What is the ratio of the Aid flow (current US$) in Nicaragua in 2006 to that in 2011?
Your answer should be very brief. 1.81. What is the ratio of the Aid flow (current US$) of South Asia in 2007 to that in 2008?
Offer a terse response. 0.35. What is the ratio of the Aid flow (current US$) in Belarus in 2007 to that in 2008?
Give a very brief answer. 0.88. What is the ratio of the Aid flow (current US$) of South Asia in 2007 to that in 2009?
Offer a very short reply. 0.31. What is the ratio of the Aid flow (current US$) in Belarus in 2007 to that in 2009?
Make the answer very short. 0.65. What is the ratio of the Aid flow (current US$) in Comoros in 2007 to that in 2009?
Give a very brief answer. 0. What is the ratio of the Aid flow (current US$) in Nicaragua in 2007 to that in 2009?
Make the answer very short. 1.76. What is the ratio of the Aid flow (current US$) of South Asia in 2007 to that in 2010?
Your answer should be compact. 0.16. What is the ratio of the Aid flow (current US$) in Belarus in 2007 to that in 2010?
Your answer should be very brief. 0.27. What is the ratio of the Aid flow (current US$) of Comoros in 2007 to that in 2010?
Give a very brief answer. 0.01. What is the ratio of the Aid flow (current US$) in Nicaragua in 2007 to that in 2010?
Your response must be concise. 0.89. What is the ratio of the Aid flow (current US$) of South Asia in 2007 to that in 2011?
Your answer should be very brief. 0.15. What is the ratio of the Aid flow (current US$) in Belarus in 2007 to that in 2011?
Provide a short and direct response. 4.62. What is the ratio of the Aid flow (current US$) in Comoros in 2007 to that in 2011?
Your answer should be compact. 0. What is the ratio of the Aid flow (current US$) in Nicaragua in 2007 to that in 2011?
Your answer should be very brief. 1.55. What is the ratio of the Aid flow (current US$) of South Asia in 2008 to that in 2009?
Offer a terse response. 0.89. What is the ratio of the Aid flow (current US$) in Belarus in 2008 to that in 2009?
Keep it short and to the point. 0.74. What is the ratio of the Aid flow (current US$) of Comoros in 2008 to that in 2009?
Your answer should be compact. 0.01. What is the ratio of the Aid flow (current US$) of Nicaragua in 2008 to that in 2009?
Your answer should be very brief. 2.52. What is the ratio of the Aid flow (current US$) of South Asia in 2008 to that in 2010?
Offer a very short reply. 0.46. What is the ratio of the Aid flow (current US$) in Belarus in 2008 to that in 2010?
Offer a terse response. 0.3. What is the ratio of the Aid flow (current US$) of Comoros in 2008 to that in 2010?
Your response must be concise. 0.04. What is the ratio of the Aid flow (current US$) of Nicaragua in 2008 to that in 2010?
Ensure brevity in your answer.  1.27. What is the ratio of the Aid flow (current US$) of South Asia in 2008 to that in 2011?
Give a very brief answer. 0.43. What is the ratio of the Aid flow (current US$) in Belarus in 2008 to that in 2011?
Make the answer very short. 5.25. What is the ratio of the Aid flow (current US$) in Comoros in 2008 to that in 2011?
Offer a terse response. 0.01. What is the ratio of the Aid flow (current US$) of Nicaragua in 2008 to that in 2011?
Provide a short and direct response. 2.21. What is the ratio of the Aid flow (current US$) of South Asia in 2009 to that in 2010?
Your answer should be very brief. 0.52. What is the ratio of the Aid flow (current US$) in Belarus in 2009 to that in 2010?
Ensure brevity in your answer.  0.41. What is the ratio of the Aid flow (current US$) in Comoros in 2009 to that in 2010?
Make the answer very short. 7.57. What is the ratio of the Aid flow (current US$) in Nicaragua in 2009 to that in 2010?
Offer a terse response. 0.51. What is the ratio of the Aid flow (current US$) of South Asia in 2009 to that in 2011?
Make the answer very short. 0.49. What is the ratio of the Aid flow (current US$) of Belarus in 2009 to that in 2011?
Your response must be concise. 7.12. What is the ratio of the Aid flow (current US$) in Comoros in 2009 to that in 2011?
Keep it short and to the point. 1.45. What is the ratio of the Aid flow (current US$) of Nicaragua in 2009 to that in 2011?
Ensure brevity in your answer.  0.88. What is the ratio of the Aid flow (current US$) in South Asia in 2010 to that in 2011?
Your answer should be very brief. 0.94. What is the ratio of the Aid flow (current US$) of Belarus in 2010 to that in 2011?
Offer a very short reply. 17.38. What is the ratio of the Aid flow (current US$) in Comoros in 2010 to that in 2011?
Provide a succinct answer. 0.19. What is the ratio of the Aid flow (current US$) of Nicaragua in 2010 to that in 2011?
Your answer should be compact. 1.74. What is the difference between the highest and the second highest Aid flow (current US$) of South Asia?
Your answer should be compact. 1.35e+08. What is the difference between the highest and the second highest Aid flow (current US$) in Belarus?
Provide a short and direct response. 8.20e+05. What is the difference between the highest and the second highest Aid flow (current US$) in Comoros?
Give a very brief answer. 1.64e+06. What is the difference between the highest and the second highest Aid flow (current US$) in Nicaragua?
Make the answer very short. 5.46e+06. What is the difference between the highest and the lowest Aid flow (current US$) of South Asia?
Give a very brief answer. 2.05e+09. What is the difference between the highest and the lowest Aid flow (current US$) of Belarus?
Make the answer very short. 1.31e+06. What is the difference between the highest and the lowest Aid flow (current US$) of Comoros?
Provide a succinct answer. 5.29e+06. What is the difference between the highest and the lowest Aid flow (current US$) of Nicaragua?
Ensure brevity in your answer.  3.18e+07. 